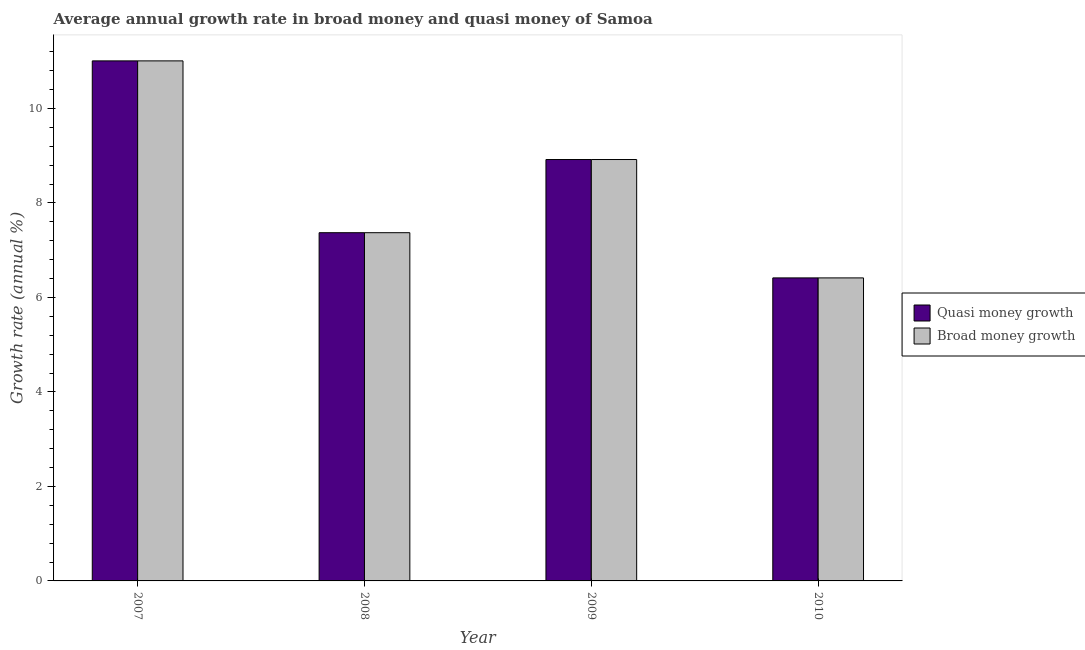How many bars are there on the 3rd tick from the left?
Keep it short and to the point. 2. What is the annual growth rate in broad money in 2009?
Ensure brevity in your answer.  8.92. Across all years, what is the maximum annual growth rate in broad money?
Offer a very short reply. 11.01. Across all years, what is the minimum annual growth rate in quasi money?
Give a very brief answer. 6.41. In which year was the annual growth rate in quasi money maximum?
Offer a terse response. 2007. In which year was the annual growth rate in quasi money minimum?
Your answer should be very brief. 2010. What is the total annual growth rate in broad money in the graph?
Ensure brevity in your answer.  33.71. What is the difference between the annual growth rate in broad money in 2009 and that in 2010?
Offer a terse response. 2.51. What is the difference between the annual growth rate in quasi money in 2010 and the annual growth rate in broad money in 2009?
Keep it short and to the point. -2.51. What is the average annual growth rate in quasi money per year?
Your response must be concise. 8.43. In the year 2009, what is the difference between the annual growth rate in quasi money and annual growth rate in broad money?
Make the answer very short. 0. In how many years, is the annual growth rate in quasi money greater than 0.4 %?
Provide a succinct answer. 4. What is the ratio of the annual growth rate in broad money in 2007 to that in 2008?
Your answer should be very brief. 1.49. What is the difference between the highest and the second highest annual growth rate in broad money?
Your answer should be very brief. 2.09. What is the difference between the highest and the lowest annual growth rate in quasi money?
Provide a short and direct response. 4.59. In how many years, is the annual growth rate in broad money greater than the average annual growth rate in broad money taken over all years?
Offer a very short reply. 2. Is the sum of the annual growth rate in quasi money in 2009 and 2010 greater than the maximum annual growth rate in broad money across all years?
Provide a succinct answer. Yes. What does the 2nd bar from the left in 2008 represents?
Your answer should be very brief. Broad money growth. What does the 2nd bar from the right in 2009 represents?
Offer a terse response. Quasi money growth. How many bars are there?
Your answer should be very brief. 8. What is the difference between two consecutive major ticks on the Y-axis?
Provide a short and direct response. 2. Does the graph contain any zero values?
Give a very brief answer. No. Does the graph contain grids?
Your answer should be very brief. No. Where does the legend appear in the graph?
Provide a short and direct response. Center right. How many legend labels are there?
Your answer should be very brief. 2. What is the title of the graph?
Keep it short and to the point. Average annual growth rate in broad money and quasi money of Samoa. What is the label or title of the X-axis?
Make the answer very short. Year. What is the label or title of the Y-axis?
Ensure brevity in your answer.  Growth rate (annual %). What is the Growth rate (annual %) in Quasi money growth in 2007?
Provide a succinct answer. 11.01. What is the Growth rate (annual %) in Broad money growth in 2007?
Give a very brief answer. 11.01. What is the Growth rate (annual %) in Quasi money growth in 2008?
Keep it short and to the point. 7.37. What is the Growth rate (annual %) in Broad money growth in 2008?
Offer a very short reply. 7.37. What is the Growth rate (annual %) of Quasi money growth in 2009?
Provide a short and direct response. 8.92. What is the Growth rate (annual %) of Broad money growth in 2009?
Keep it short and to the point. 8.92. What is the Growth rate (annual %) in Quasi money growth in 2010?
Offer a very short reply. 6.41. What is the Growth rate (annual %) in Broad money growth in 2010?
Give a very brief answer. 6.41. Across all years, what is the maximum Growth rate (annual %) of Quasi money growth?
Give a very brief answer. 11.01. Across all years, what is the maximum Growth rate (annual %) of Broad money growth?
Your answer should be compact. 11.01. Across all years, what is the minimum Growth rate (annual %) of Quasi money growth?
Your answer should be very brief. 6.41. Across all years, what is the minimum Growth rate (annual %) in Broad money growth?
Ensure brevity in your answer.  6.41. What is the total Growth rate (annual %) in Quasi money growth in the graph?
Keep it short and to the point. 33.71. What is the total Growth rate (annual %) of Broad money growth in the graph?
Your response must be concise. 33.71. What is the difference between the Growth rate (annual %) of Quasi money growth in 2007 and that in 2008?
Ensure brevity in your answer.  3.64. What is the difference between the Growth rate (annual %) in Broad money growth in 2007 and that in 2008?
Offer a very short reply. 3.64. What is the difference between the Growth rate (annual %) of Quasi money growth in 2007 and that in 2009?
Keep it short and to the point. 2.09. What is the difference between the Growth rate (annual %) in Broad money growth in 2007 and that in 2009?
Your response must be concise. 2.09. What is the difference between the Growth rate (annual %) in Quasi money growth in 2007 and that in 2010?
Provide a succinct answer. 4.59. What is the difference between the Growth rate (annual %) of Broad money growth in 2007 and that in 2010?
Ensure brevity in your answer.  4.59. What is the difference between the Growth rate (annual %) in Quasi money growth in 2008 and that in 2009?
Your answer should be very brief. -1.55. What is the difference between the Growth rate (annual %) of Broad money growth in 2008 and that in 2009?
Ensure brevity in your answer.  -1.55. What is the difference between the Growth rate (annual %) in Quasi money growth in 2008 and that in 2010?
Offer a very short reply. 0.96. What is the difference between the Growth rate (annual %) of Broad money growth in 2008 and that in 2010?
Make the answer very short. 0.96. What is the difference between the Growth rate (annual %) of Quasi money growth in 2009 and that in 2010?
Your answer should be very brief. 2.51. What is the difference between the Growth rate (annual %) in Broad money growth in 2009 and that in 2010?
Your answer should be compact. 2.51. What is the difference between the Growth rate (annual %) of Quasi money growth in 2007 and the Growth rate (annual %) of Broad money growth in 2008?
Provide a succinct answer. 3.64. What is the difference between the Growth rate (annual %) of Quasi money growth in 2007 and the Growth rate (annual %) of Broad money growth in 2009?
Offer a very short reply. 2.09. What is the difference between the Growth rate (annual %) of Quasi money growth in 2007 and the Growth rate (annual %) of Broad money growth in 2010?
Give a very brief answer. 4.59. What is the difference between the Growth rate (annual %) in Quasi money growth in 2008 and the Growth rate (annual %) in Broad money growth in 2009?
Offer a terse response. -1.55. What is the difference between the Growth rate (annual %) in Quasi money growth in 2008 and the Growth rate (annual %) in Broad money growth in 2010?
Your answer should be compact. 0.96. What is the difference between the Growth rate (annual %) in Quasi money growth in 2009 and the Growth rate (annual %) in Broad money growth in 2010?
Ensure brevity in your answer.  2.51. What is the average Growth rate (annual %) of Quasi money growth per year?
Your answer should be compact. 8.43. What is the average Growth rate (annual %) in Broad money growth per year?
Offer a terse response. 8.43. What is the ratio of the Growth rate (annual %) of Quasi money growth in 2007 to that in 2008?
Your answer should be compact. 1.49. What is the ratio of the Growth rate (annual %) in Broad money growth in 2007 to that in 2008?
Your response must be concise. 1.49. What is the ratio of the Growth rate (annual %) of Quasi money growth in 2007 to that in 2009?
Keep it short and to the point. 1.23. What is the ratio of the Growth rate (annual %) of Broad money growth in 2007 to that in 2009?
Make the answer very short. 1.23. What is the ratio of the Growth rate (annual %) in Quasi money growth in 2007 to that in 2010?
Your answer should be very brief. 1.72. What is the ratio of the Growth rate (annual %) in Broad money growth in 2007 to that in 2010?
Ensure brevity in your answer.  1.72. What is the ratio of the Growth rate (annual %) in Quasi money growth in 2008 to that in 2009?
Your answer should be very brief. 0.83. What is the ratio of the Growth rate (annual %) in Broad money growth in 2008 to that in 2009?
Provide a succinct answer. 0.83. What is the ratio of the Growth rate (annual %) in Quasi money growth in 2008 to that in 2010?
Keep it short and to the point. 1.15. What is the ratio of the Growth rate (annual %) of Broad money growth in 2008 to that in 2010?
Keep it short and to the point. 1.15. What is the ratio of the Growth rate (annual %) in Quasi money growth in 2009 to that in 2010?
Your answer should be very brief. 1.39. What is the ratio of the Growth rate (annual %) of Broad money growth in 2009 to that in 2010?
Your response must be concise. 1.39. What is the difference between the highest and the second highest Growth rate (annual %) of Quasi money growth?
Keep it short and to the point. 2.09. What is the difference between the highest and the second highest Growth rate (annual %) in Broad money growth?
Your answer should be very brief. 2.09. What is the difference between the highest and the lowest Growth rate (annual %) of Quasi money growth?
Your response must be concise. 4.59. What is the difference between the highest and the lowest Growth rate (annual %) in Broad money growth?
Make the answer very short. 4.59. 